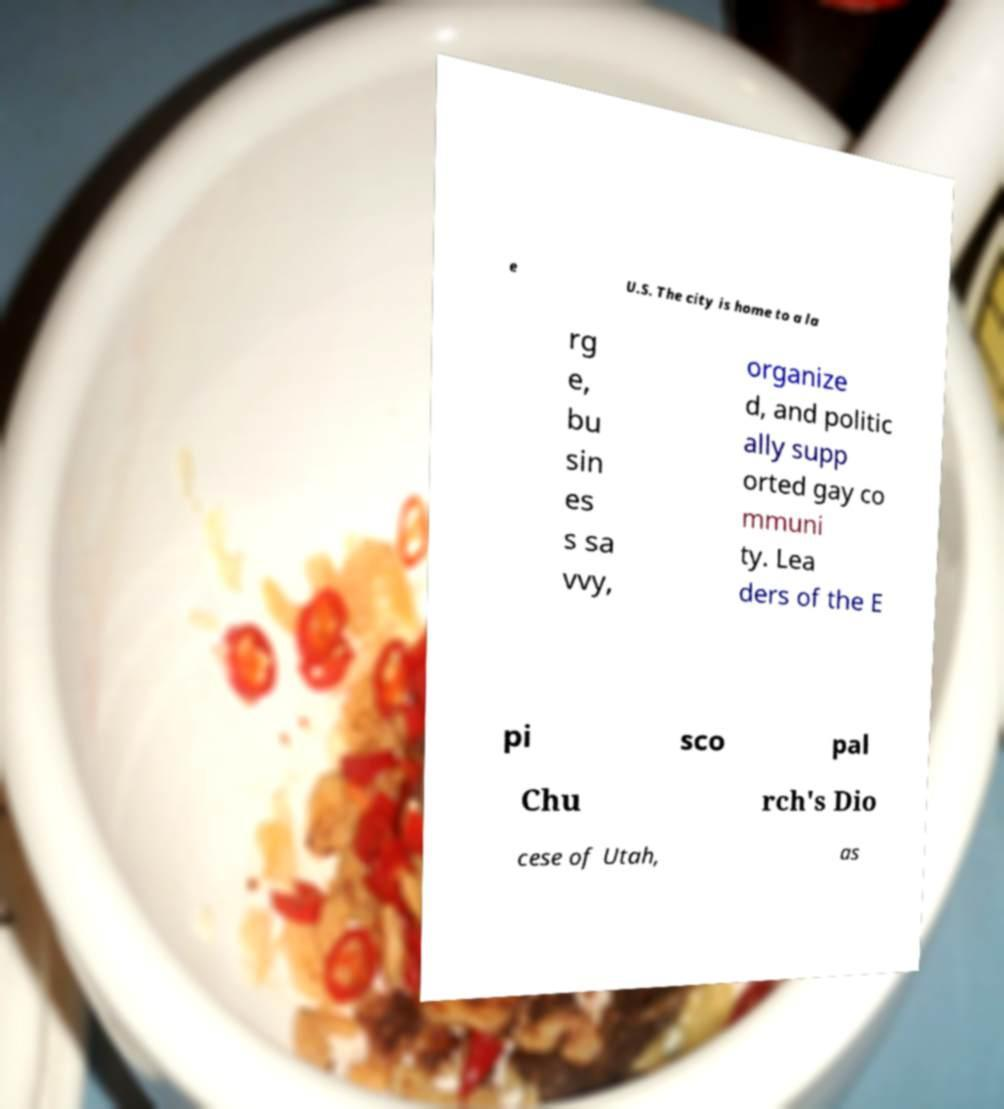Could you extract and type out the text from this image? e U.S. The city is home to a la rg e, bu sin es s sa vvy, organize d, and politic ally supp orted gay co mmuni ty. Lea ders of the E pi sco pal Chu rch's Dio cese of Utah, as 